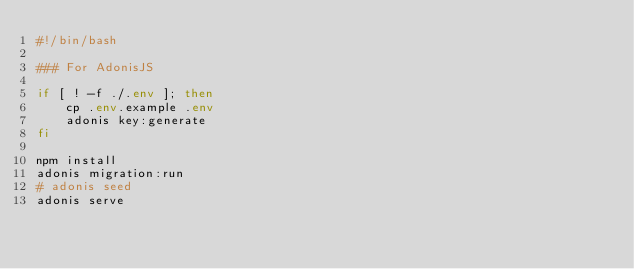<code> <loc_0><loc_0><loc_500><loc_500><_Bash_>#!/bin/bash

### For AdonisJS

if [ ! -f ./.env ]; then
    cp .env.example .env
    adonis key:generate
fi

npm install
adonis migration:run
# adonis seed
adonis serve
</code> 